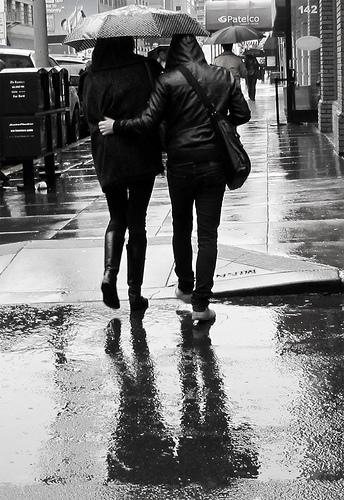What kind of weather is happening?
Give a very brief answer. Rain. Is this photo color?
Concise answer only. No. What are women walking under on the sidewalk?
Be succinct. Umbrella. 